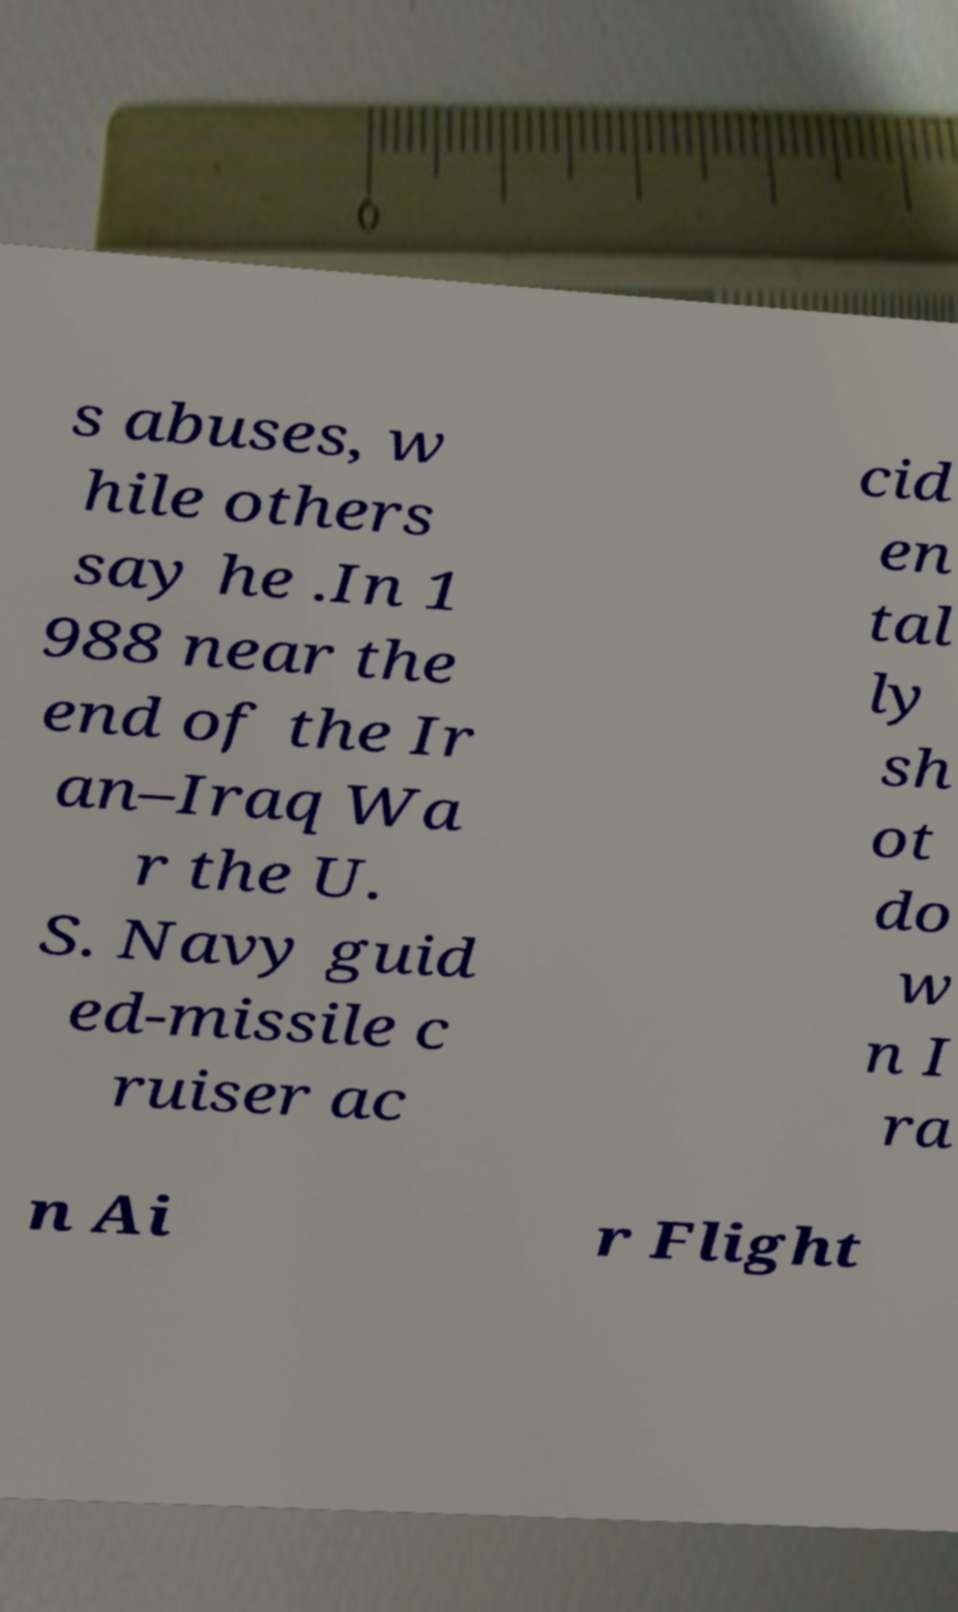Can you read and provide the text displayed in the image?This photo seems to have some interesting text. Can you extract and type it out for me? s abuses, w hile others say he .In 1 988 near the end of the Ir an–Iraq Wa r the U. S. Navy guid ed-missile c ruiser ac cid en tal ly sh ot do w n I ra n Ai r Flight 